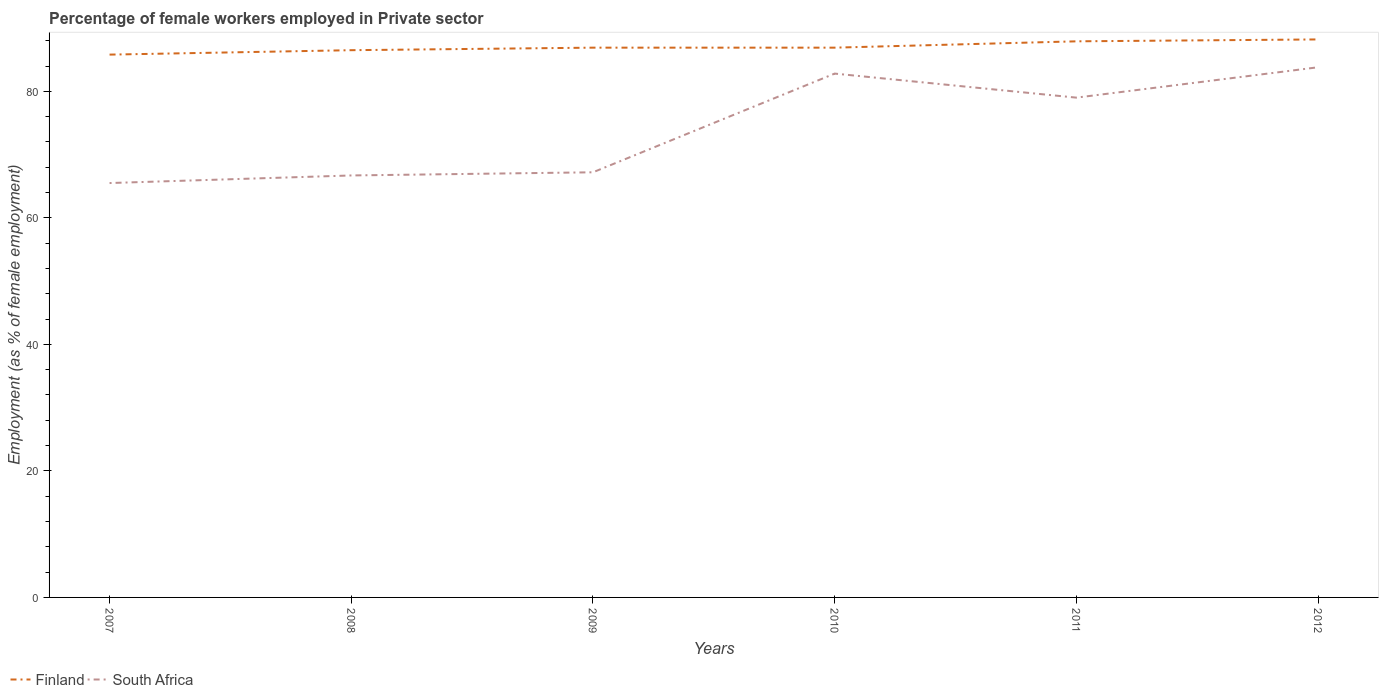Does the line corresponding to Finland intersect with the line corresponding to South Africa?
Ensure brevity in your answer.  No. Is the number of lines equal to the number of legend labels?
Your answer should be very brief. Yes. Across all years, what is the maximum percentage of females employed in Private sector in South Africa?
Provide a short and direct response. 65.5. In which year was the percentage of females employed in Private sector in Finland maximum?
Make the answer very short. 2007. What is the total percentage of females employed in Private sector in South Africa in the graph?
Your answer should be compact. -18.3. What is the difference between the highest and the second highest percentage of females employed in Private sector in South Africa?
Keep it short and to the point. 18.3. What is the difference between the highest and the lowest percentage of females employed in Private sector in Finland?
Your answer should be very brief. 2. Is the percentage of females employed in Private sector in Finland strictly greater than the percentage of females employed in Private sector in South Africa over the years?
Your response must be concise. No. How many lines are there?
Your answer should be compact. 2. How many years are there in the graph?
Your answer should be very brief. 6. What is the difference between two consecutive major ticks on the Y-axis?
Your answer should be very brief. 20. Are the values on the major ticks of Y-axis written in scientific E-notation?
Make the answer very short. No. How are the legend labels stacked?
Ensure brevity in your answer.  Horizontal. What is the title of the graph?
Your answer should be very brief. Percentage of female workers employed in Private sector. Does "United Arab Emirates" appear as one of the legend labels in the graph?
Ensure brevity in your answer.  No. What is the label or title of the X-axis?
Your answer should be compact. Years. What is the label or title of the Y-axis?
Offer a very short reply. Employment (as % of female employment). What is the Employment (as % of female employment) of Finland in 2007?
Give a very brief answer. 85.8. What is the Employment (as % of female employment) of South Africa in 2007?
Offer a very short reply. 65.5. What is the Employment (as % of female employment) of Finland in 2008?
Your response must be concise. 86.5. What is the Employment (as % of female employment) in South Africa in 2008?
Keep it short and to the point. 66.7. What is the Employment (as % of female employment) of Finland in 2009?
Your response must be concise. 86.9. What is the Employment (as % of female employment) of South Africa in 2009?
Your answer should be compact. 67.2. What is the Employment (as % of female employment) of Finland in 2010?
Give a very brief answer. 86.9. What is the Employment (as % of female employment) of South Africa in 2010?
Your answer should be very brief. 82.8. What is the Employment (as % of female employment) in Finland in 2011?
Offer a terse response. 87.9. What is the Employment (as % of female employment) of South Africa in 2011?
Offer a terse response. 79. What is the Employment (as % of female employment) of Finland in 2012?
Give a very brief answer. 88.2. What is the Employment (as % of female employment) in South Africa in 2012?
Your answer should be compact. 83.8. Across all years, what is the maximum Employment (as % of female employment) of Finland?
Make the answer very short. 88.2. Across all years, what is the maximum Employment (as % of female employment) of South Africa?
Offer a very short reply. 83.8. Across all years, what is the minimum Employment (as % of female employment) of Finland?
Give a very brief answer. 85.8. Across all years, what is the minimum Employment (as % of female employment) in South Africa?
Offer a terse response. 65.5. What is the total Employment (as % of female employment) of Finland in the graph?
Provide a succinct answer. 522.2. What is the total Employment (as % of female employment) in South Africa in the graph?
Give a very brief answer. 445. What is the difference between the Employment (as % of female employment) in Finland in 2007 and that in 2008?
Keep it short and to the point. -0.7. What is the difference between the Employment (as % of female employment) of South Africa in 2007 and that in 2008?
Your answer should be compact. -1.2. What is the difference between the Employment (as % of female employment) in South Africa in 2007 and that in 2010?
Offer a very short reply. -17.3. What is the difference between the Employment (as % of female employment) in Finland in 2007 and that in 2011?
Offer a terse response. -2.1. What is the difference between the Employment (as % of female employment) in South Africa in 2007 and that in 2012?
Your answer should be compact. -18.3. What is the difference between the Employment (as % of female employment) of Finland in 2008 and that in 2010?
Keep it short and to the point. -0.4. What is the difference between the Employment (as % of female employment) of South Africa in 2008 and that in 2010?
Keep it short and to the point. -16.1. What is the difference between the Employment (as % of female employment) of Finland in 2008 and that in 2012?
Provide a succinct answer. -1.7. What is the difference between the Employment (as % of female employment) of South Africa in 2008 and that in 2012?
Provide a short and direct response. -17.1. What is the difference between the Employment (as % of female employment) of South Africa in 2009 and that in 2010?
Keep it short and to the point. -15.6. What is the difference between the Employment (as % of female employment) in Finland in 2009 and that in 2012?
Offer a terse response. -1.3. What is the difference between the Employment (as % of female employment) in South Africa in 2009 and that in 2012?
Your response must be concise. -16.6. What is the difference between the Employment (as % of female employment) in Finland in 2010 and that in 2011?
Offer a very short reply. -1. What is the difference between the Employment (as % of female employment) of Finland in 2010 and that in 2012?
Keep it short and to the point. -1.3. What is the difference between the Employment (as % of female employment) of South Africa in 2010 and that in 2012?
Make the answer very short. -1. What is the difference between the Employment (as % of female employment) in Finland in 2011 and that in 2012?
Your answer should be very brief. -0.3. What is the difference between the Employment (as % of female employment) in South Africa in 2011 and that in 2012?
Your answer should be compact. -4.8. What is the difference between the Employment (as % of female employment) of Finland in 2007 and the Employment (as % of female employment) of South Africa in 2008?
Keep it short and to the point. 19.1. What is the difference between the Employment (as % of female employment) of Finland in 2007 and the Employment (as % of female employment) of South Africa in 2010?
Offer a terse response. 3. What is the difference between the Employment (as % of female employment) of Finland in 2008 and the Employment (as % of female employment) of South Africa in 2009?
Give a very brief answer. 19.3. What is the difference between the Employment (as % of female employment) of Finland in 2008 and the Employment (as % of female employment) of South Africa in 2010?
Keep it short and to the point. 3.7. What is the difference between the Employment (as % of female employment) of Finland in 2008 and the Employment (as % of female employment) of South Africa in 2012?
Give a very brief answer. 2.7. What is the difference between the Employment (as % of female employment) of Finland in 2010 and the Employment (as % of female employment) of South Africa in 2011?
Make the answer very short. 7.9. What is the difference between the Employment (as % of female employment) in Finland in 2010 and the Employment (as % of female employment) in South Africa in 2012?
Provide a succinct answer. 3.1. What is the difference between the Employment (as % of female employment) of Finland in 2011 and the Employment (as % of female employment) of South Africa in 2012?
Provide a short and direct response. 4.1. What is the average Employment (as % of female employment) in Finland per year?
Make the answer very short. 87.03. What is the average Employment (as % of female employment) of South Africa per year?
Provide a succinct answer. 74.17. In the year 2007, what is the difference between the Employment (as % of female employment) in Finland and Employment (as % of female employment) in South Africa?
Ensure brevity in your answer.  20.3. In the year 2008, what is the difference between the Employment (as % of female employment) in Finland and Employment (as % of female employment) in South Africa?
Your response must be concise. 19.8. In the year 2009, what is the difference between the Employment (as % of female employment) in Finland and Employment (as % of female employment) in South Africa?
Offer a terse response. 19.7. In the year 2010, what is the difference between the Employment (as % of female employment) in Finland and Employment (as % of female employment) in South Africa?
Your response must be concise. 4.1. What is the ratio of the Employment (as % of female employment) in South Africa in 2007 to that in 2008?
Keep it short and to the point. 0.98. What is the ratio of the Employment (as % of female employment) in Finland in 2007 to that in 2009?
Provide a succinct answer. 0.99. What is the ratio of the Employment (as % of female employment) in South Africa in 2007 to that in 2009?
Provide a succinct answer. 0.97. What is the ratio of the Employment (as % of female employment) of Finland in 2007 to that in 2010?
Provide a short and direct response. 0.99. What is the ratio of the Employment (as % of female employment) of South Africa in 2007 to that in 2010?
Provide a short and direct response. 0.79. What is the ratio of the Employment (as % of female employment) of Finland in 2007 to that in 2011?
Offer a very short reply. 0.98. What is the ratio of the Employment (as % of female employment) in South Africa in 2007 to that in 2011?
Offer a very short reply. 0.83. What is the ratio of the Employment (as % of female employment) of Finland in 2007 to that in 2012?
Offer a very short reply. 0.97. What is the ratio of the Employment (as % of female employment) of South Africa in 2007 to that in 2012?
Your response must be concise. 0.78. What is the ratio of the Employment (as % of female employment) in Finland in 2008 to that in 2010?
Ensure brevity in your answer.  1. What is the ratio of the Employment (as % of female employment) in South Africa in 2008 to that in 2010?
Make the answer very short. 0.81. What is the ratio of the Employment (as % of female employment) in Finland in 2008 to that in 2011?
Ensure brevity in your answer.  0.98. What is the ratio of the Employment (as % of female employment) of South Africa in 2008 to that in 2011?
Provide a short and direct response. 0.84. What is the ratio of the Employment (as % of female employment) of Finland in 2008 to that in 2012?
Offer a terse response. 0.98. What is the ratio of the Employment (as % of female employment) in South Africa in 2008 to that in 2012?
Offer a very short reply. 0.8. What is the ratio of the Employment (as % of female employment) of Finland in 2009 to that in 2010?
Offer a terse response. 1. What is the ratio of the Employment (as % of female employment) of South Africa in 2009 to that in 2010?
Your answer should be compact. 0.81. What is the ratio of the Employment (as % of female employment) in Finland in 2009 to that in 2011?
Make the answer very short. 0.99. What is the ratio of the Employment (as % of female employment) in South Africa in 2009 to that in 2011?
Provide a short and direct response. 0.85. What is the ratio of the Employment (as % of female employment) of Finland in 2009 to that in 2012?
Your answer should be compact. 0.99. What is the ratio of the Employment (as % of female employment) in South Africa in 2009 to that in 2012?
Your answer should be very brief. 0.8. What is the ratio of the Employment (as % of female employment) in Finland in 2010 to that in 2011?
Your response must be concise. 0.99. What is the ratio of the Employment (as % of female employment) in South Africa in 2010 to that in 2011?
Offer a very short reply. 1.05. What is the ratio of the Employment (as % of female employment) of Finland in 2010 to that in 2012?
Provide a short and direct response. 0.99. What is the ratio of the Employment (as % of female employment) in South Africa in 2010 to that in 2012?
Your answer should be compact. 0.99. What is the ratio of the Employment (as % of female employment) in South Africa in 2011 to that in 2012?
Your answer should be very brief. 0.94. What is the difference between the highest and the second highest Employment (as % of female employment) of South Africa?
Provide a succinct answer. 1. What is the difference between the highest and the lowest Employment (as % of female employment) of Finland?
Offer a very short reply. 2.4. 